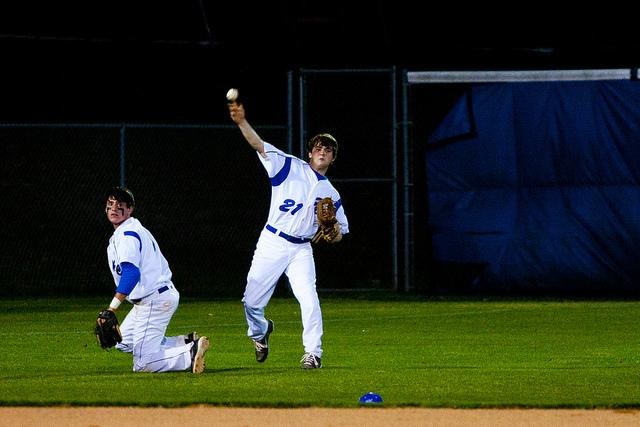What position is played by the kneeling player? Please explain your reasoning. outfield. The position is the outfield. 